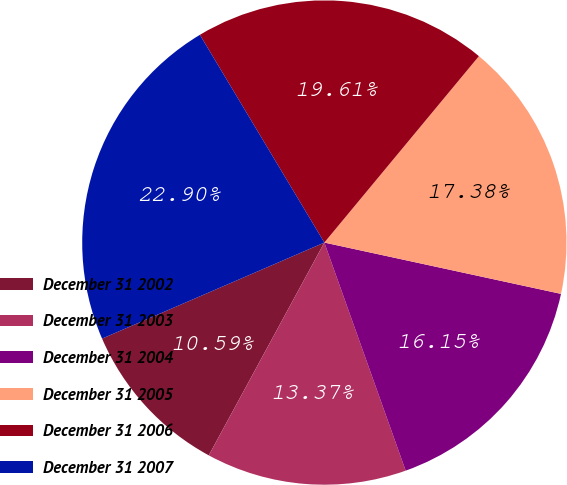Convert chart. <chart><loc_0><loc_0><loc_500><loc_500><pie_chart><fcel>December 31 2002<fcel>December 31 2003<fcel>December 31 2004<fcel>December 31 2005<fcel>December 31 2006<fcel>December 31 2007<nl><fcel>10.59%<fcel>13.37%<fcel>16.15%<fcel>17.38%<fcel>19.61%<fcel>22.9%<nl></chart> 